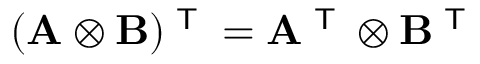<formula> <loc_0><loc_0><loc_500><loc_500>( A \otimes B ) ^ { T } = A ^ { T } \otimes B ^ { T }</formula> 